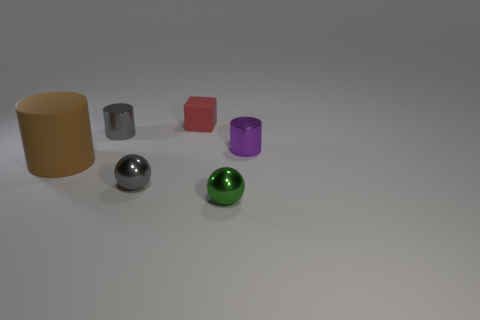How many other things are there of the same size as the purple cylinder?
Provide a short and direct response. 4. There is a metal thing behind the purple shiny object; does it have the same color as the block?
Make the answer very short. No. Are there more small purple things that are on the left side of the small green metal object than red blocks?
Provide a short and direct response. No. Is there any other thing of the same color as the cube?
Your response must be concise. No. There is a tiny gray shiny object in front of the large matte object that is in front of the small red cube; what shape is it?
Keep it short and to the point. Sphere. Is the number of big brown matte objects greater than the number of tiny things?
Your response must be concise. No. How many small shiny things are both in front of the purple metallic object and behind the small green object?
Your answer should be compact. 1. What number of large brown rubber cylinders are behind the rubber cylinder that is to the left of the small gray sphere?
Your answer should be very brief. 0. What number of things are either things that are left of the purple metallic cylinder or tiny balls that are left of the red object?
Ensure brevity in your answer.  5. There is a brown thing that is the same shape as the tiny purple object; what is its material?
Make the answer very short. Rubber. 